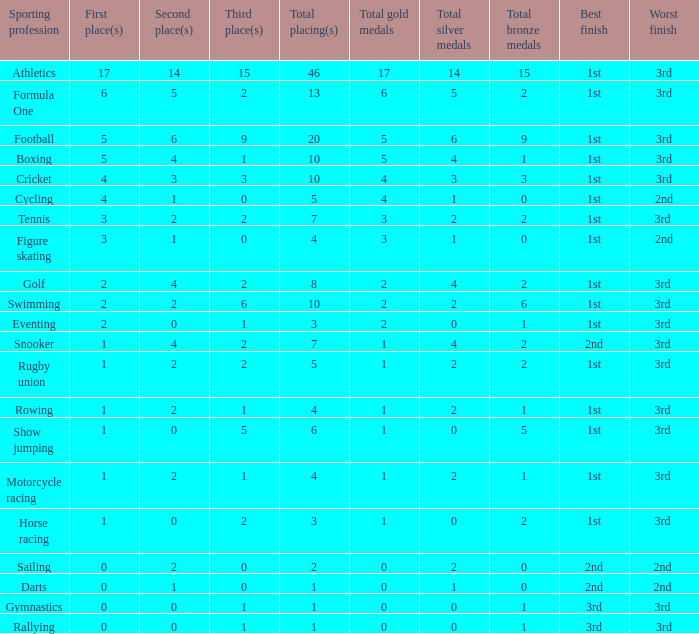How many second place showings does snooker have? 4.0. 